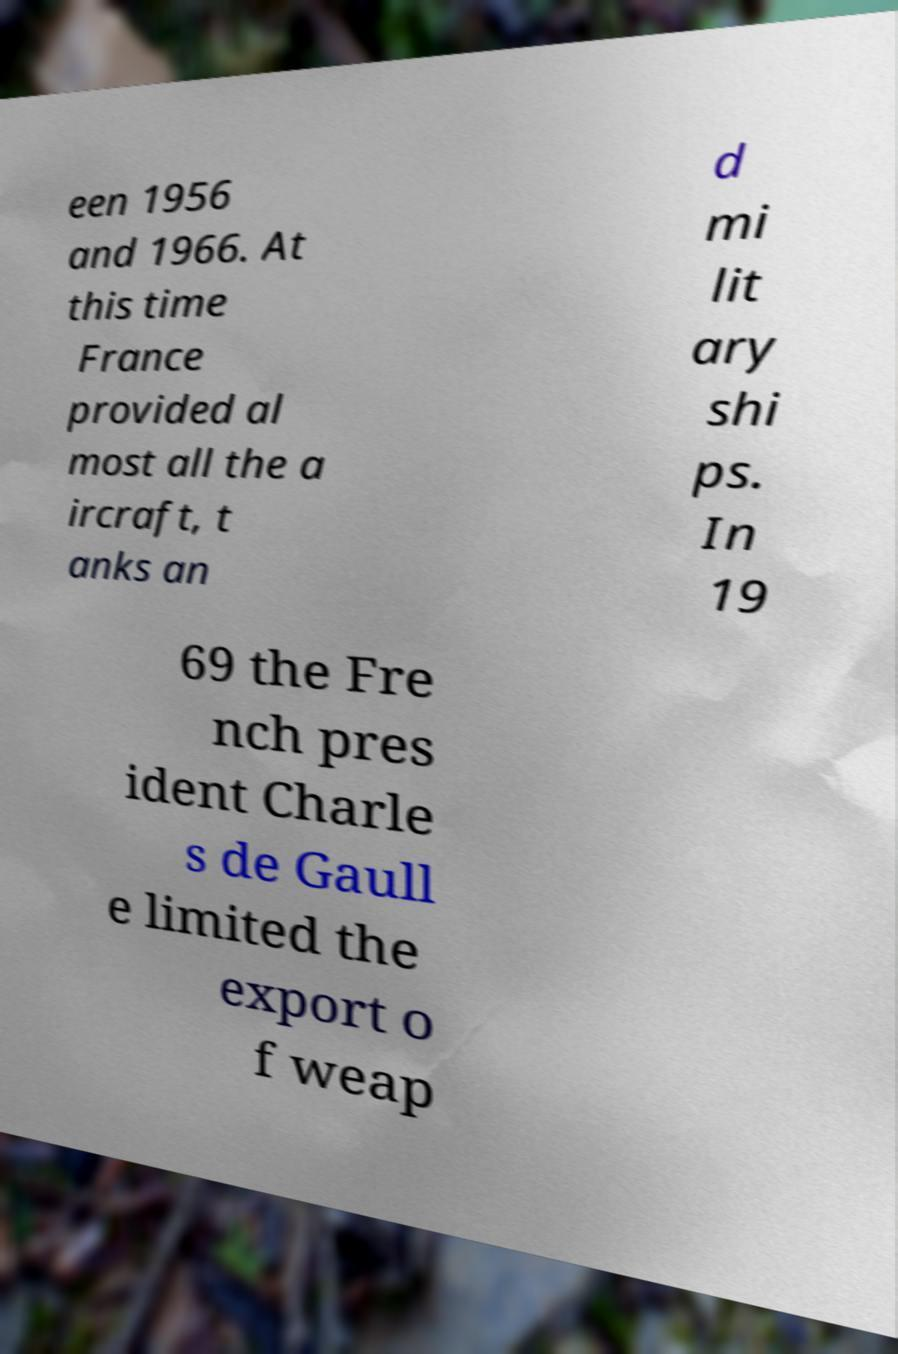What messages or text are displayed in this image? I need them in a readable, typed format. een 1956 and 1966. At this time France provided al most all the a ircraft, t anks an d mi lit ary shi ps. In 19 69 the Fre nch pres ident Charle s de Gaull e limited the export o f weap 